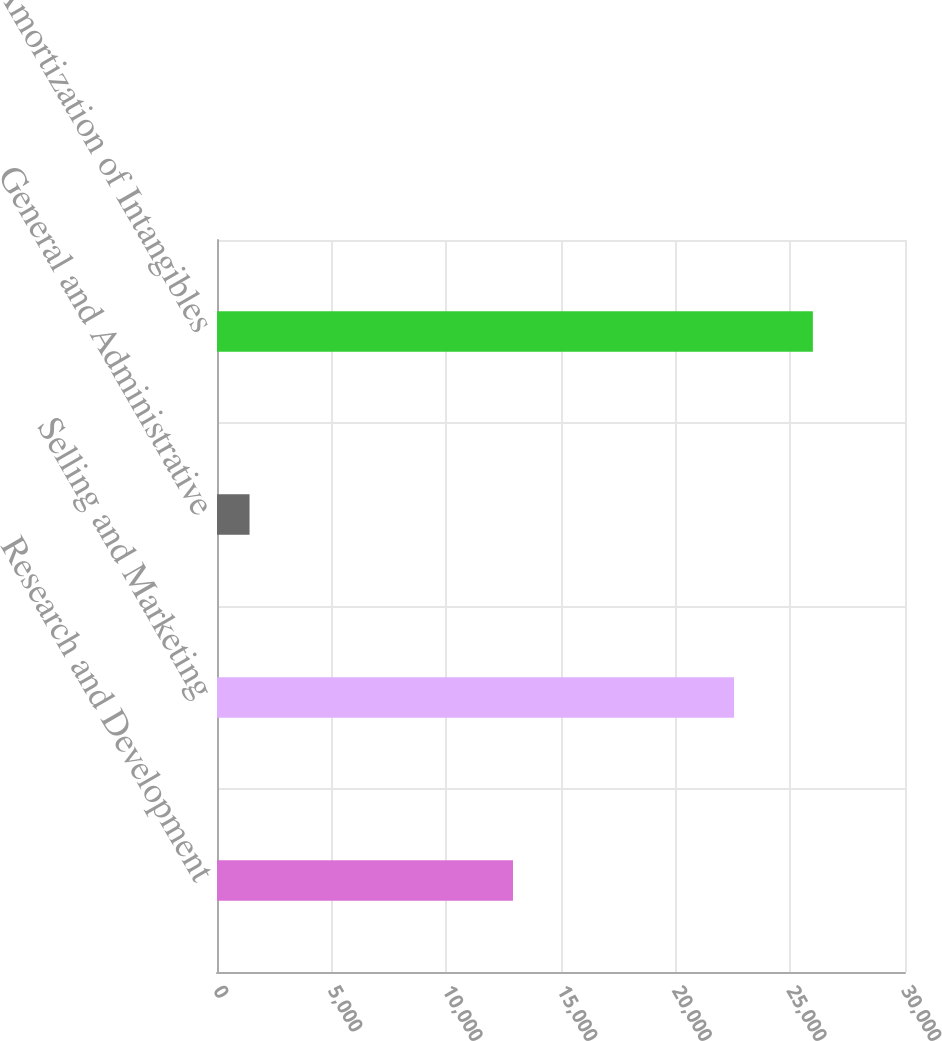<chart> <loc_0><loc_0><loc_500><loc_500><bar_chart><fcel>Research and Development<fcel>Selling and Marketing<fcel>General and Administrative<fcel>Amortization of Intangibles<nl><fcel>12907<fcel>22547<fcel>1419<fcel>25983<nl></chart> 